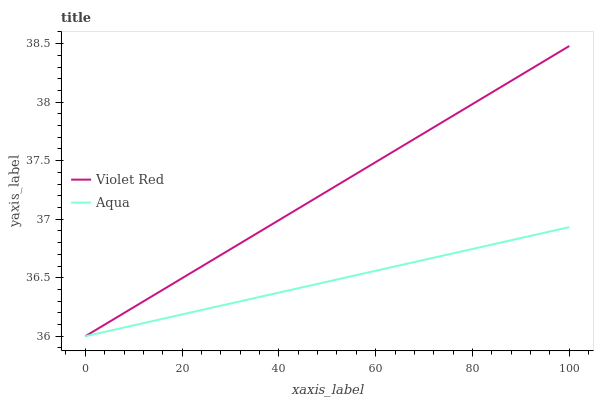Does Aqua have the maximum area under the curve?
Answer yes or no. No. Is Aqua the smoothest?
Answer yes or no. No. Does Aqua have the highest value?
Answer yes or no. No. 